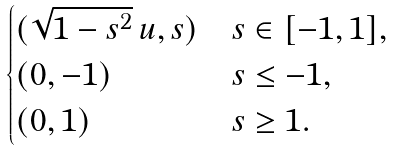Convert formula to latex. <formula><loc_0><loc_0><loc_500><loc_500>\begin{cases} ( \sqrt { 1 - s ^ { 2 } } \, u , s ) & s \in [ - 1 , 1 ] , \\ ( 0 , - 1 ) & s \leq - 1 , \\ ( 0 , 1 ) & s \geq 1 . \end{cases}</formula> 